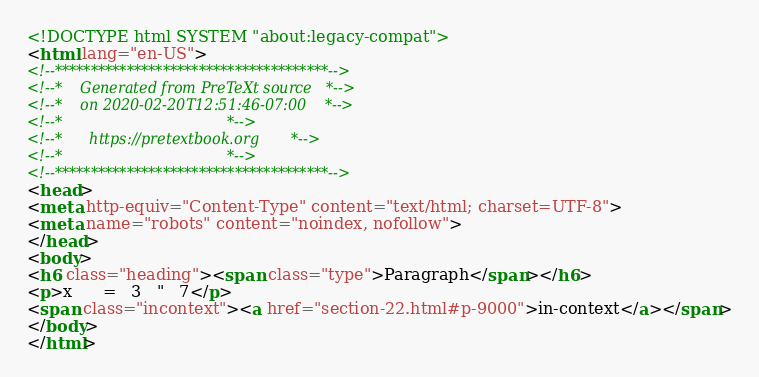<code> <loc_0><loc_0><loc_500><loc_500><_HTML_><!DOCTYPE html SYSTEM "about:legacy-compat">
<html lang="en-US">
<!--**************************************-->
<!--*    Generated from PreTeXt source   *-->
<!--*    on 2020-02-20T12:51:46-07:00    *-->
<!--*                                    *-->
<!--*      https://pretextbook.org       *-->
<!--*                                    *-->
<!--**************************************-->
<head>
<meta http-equiv="Content-Type" content="text/html; charset=UTF-8">
<meta name="robots" content="noindex, nofollow">
</head>
<body>
<h6 class="heading"><span class="type">Paragraph</span></h6>
<p>x      =   3   "   7</p>
<span class="incontext"><a href="section-22.html#p-9000">in-context</a></span>
</body>
</html>
</code> 